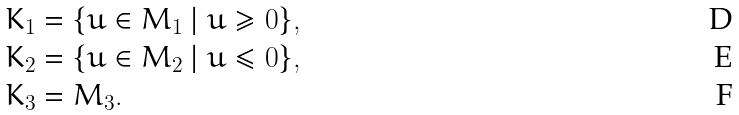Convert formula to latex. <formula><loc_0><loc_0><loc_500><loc_500>& K _ { 1 } = \{ u \in M _ { 1 } \ | \ u \geq 0 \} , \\ & K _ { 2 } = \{ u \in M _ { 2 } \ | \ u \leq 0 \} , \\ & K _ { 3 } = M _ { 3 } .</formula> 